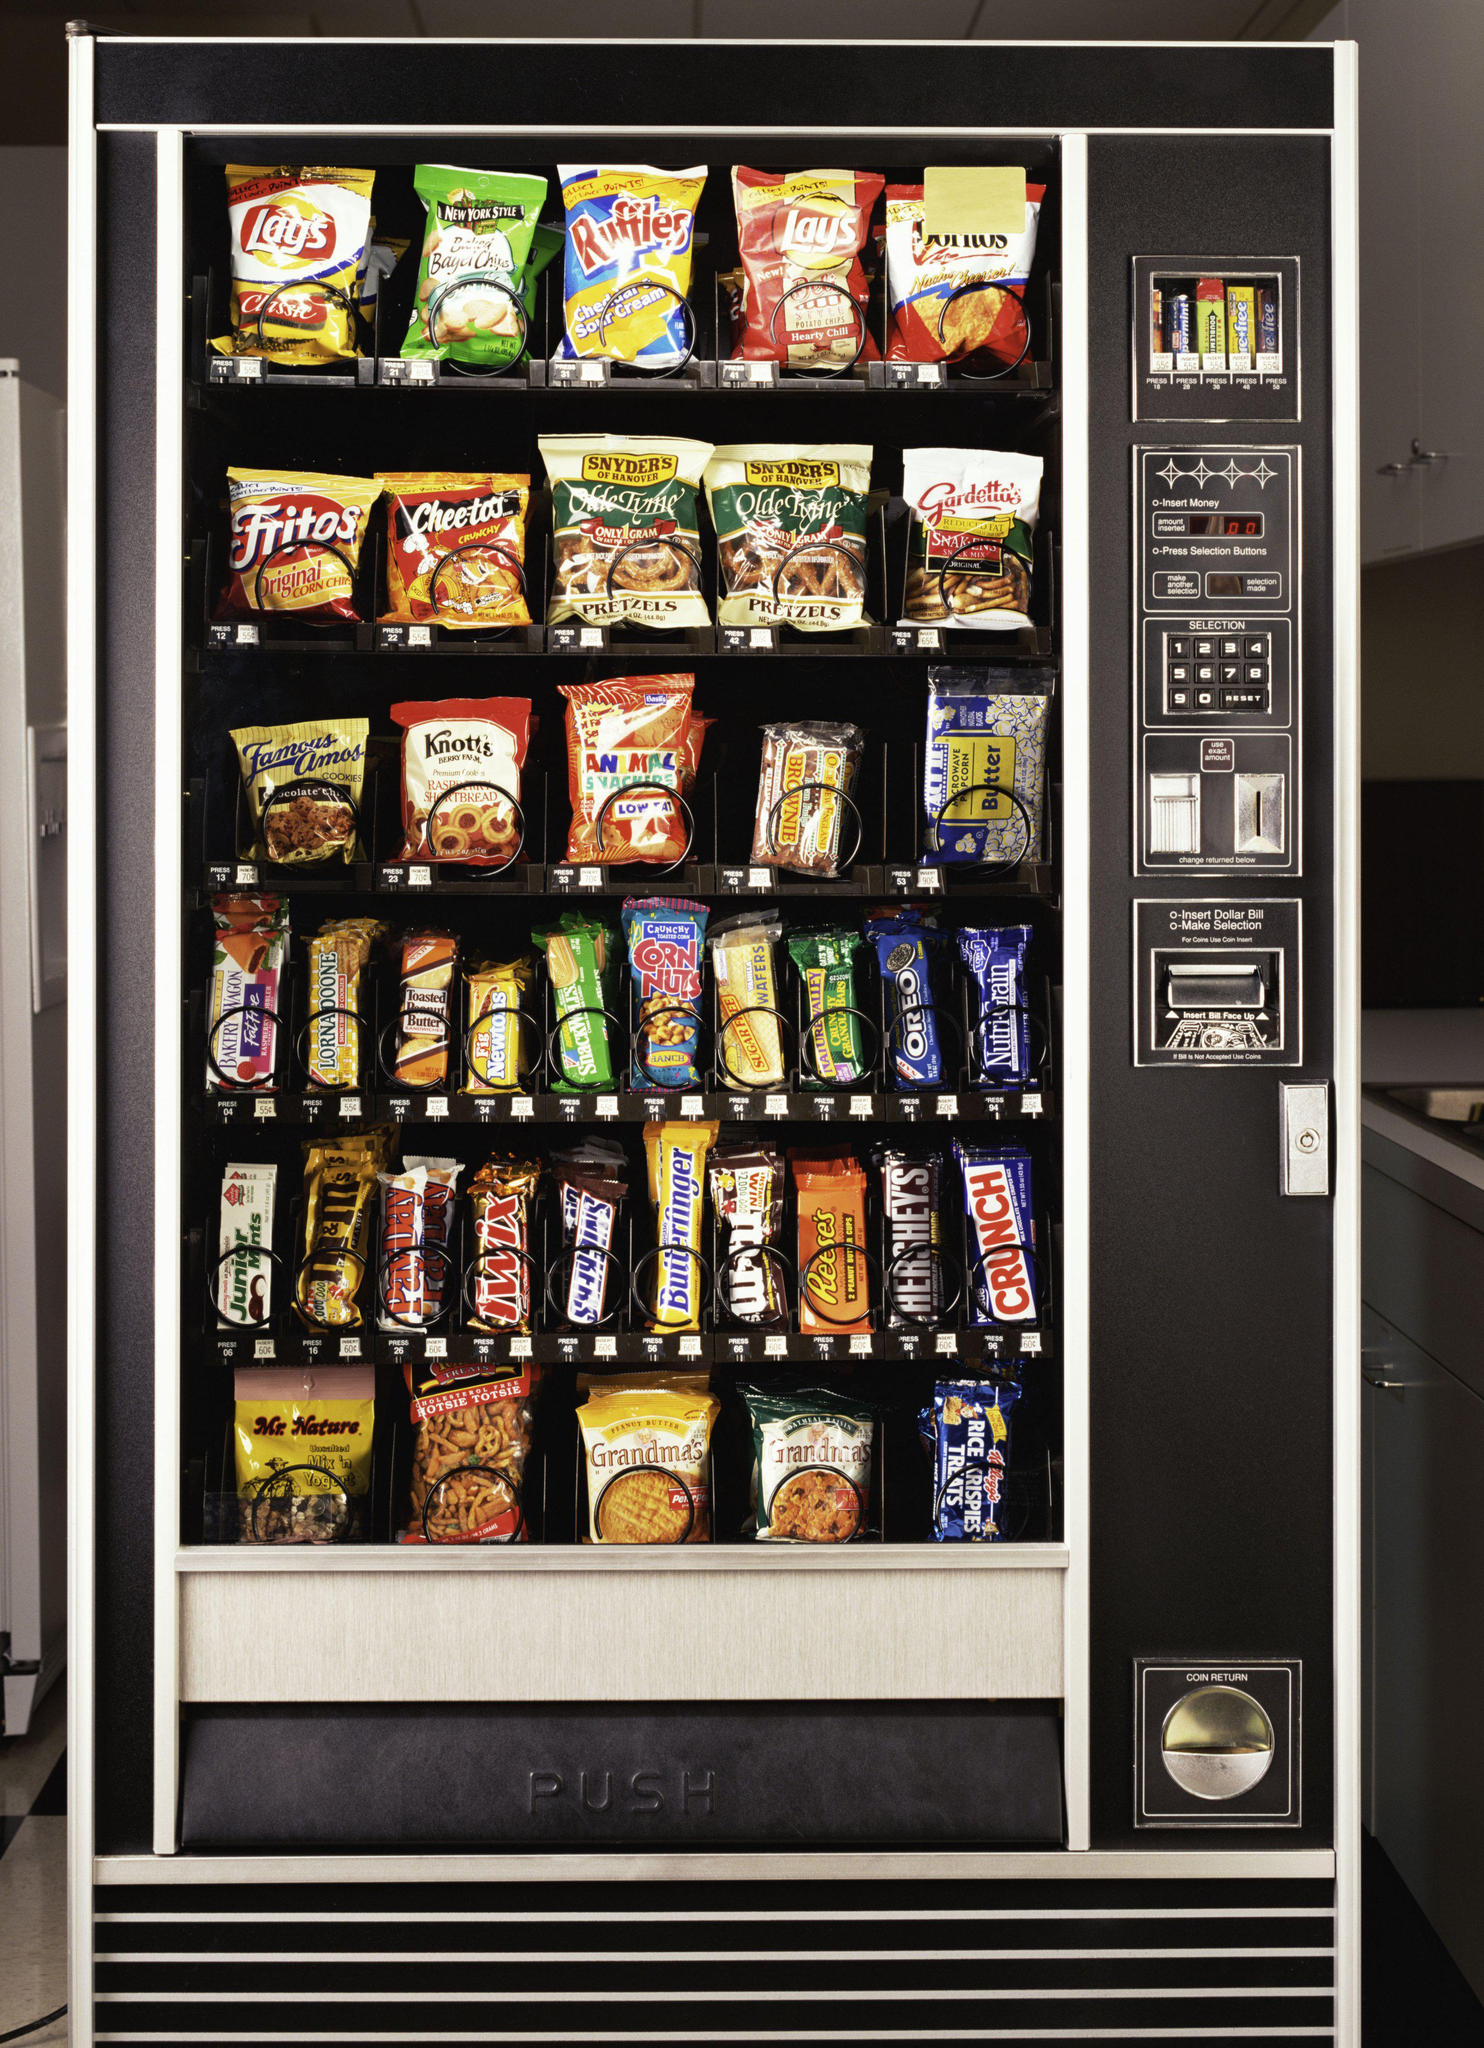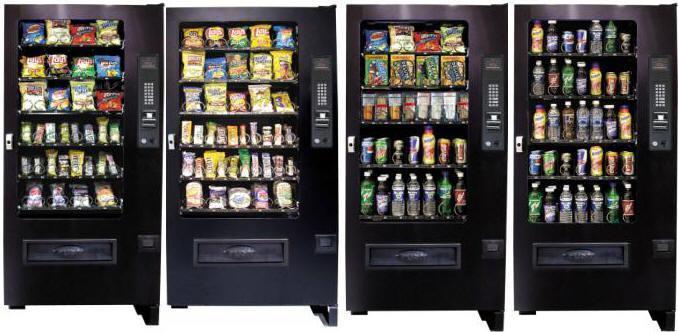The first image is the image on the left, the second image is the image on the right. Examine the images to the left and right. Is the description "There are at most three vending machines in total." accurate? Answer yes or no. No. 